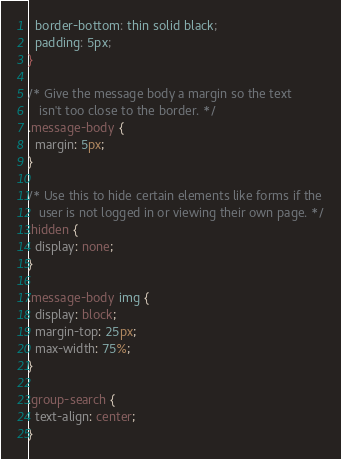Convert code to text. <code><loc_0><loc_0><loc_500><loc_500><_CSS_>  border-bottom: thin solid black;
  padding: 5px;
}

/* Give the message body a margin so the text
   isn't too close to the border. */
.message-body {
  margin: 5px;
}

/* Use this to hide certain elements like forms if the
   user is not logged in or viewing their own page. */
.hidden {
  display: none;
}

.message-body img {
  display: block;
  margin-top: 25px;
  max-width: 75%;
}

.group-search {
  text-align: center;
}</code> 